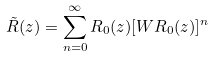Convert formula to latex. <formula><loc_0><loc_0><loc_500><loc_500>\tilde { R } ( z ) = \sum _ { n = 0 } ^ { \infty } R _ { 0 } ( z ) [ W R _ { 0 } ( z ) ] ^ { n }</formula> 